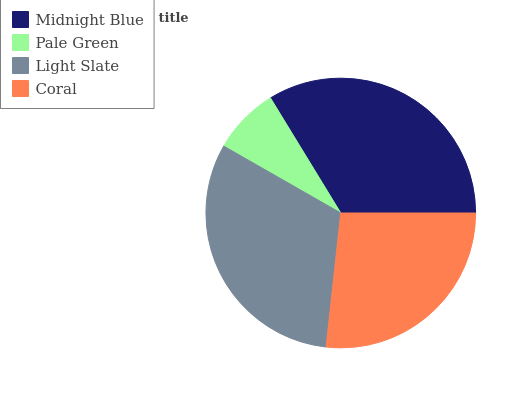Is Pale Green the minimum?
Answer yes or no. Yes. Is Midnight Blue the maximum?
Answer yes or no. Yes. Is Light Slate the minimum?
Answer yes or no. No. Is Light Slate the maximum?
Answer yes or no. No. Is Light Slate greater than Pale Green?
Answer yes or no. Yes. Is Pale Green less than Light Slate?
Answer yes or no. Yes. Is Pale Green greater than Light Slate?
Answer yes or no. No. Is Light Slate less than Pale Green?
Answer yes or no. No. Is Light Slate the high median?
Answer yes or no. Yes. Is Coral the low median?
Answer yes or no. Yes. Is Midnight Blue the high median?
Answer yes or no. No. Is Light Slate the low median?
Answer yes or no. No. 